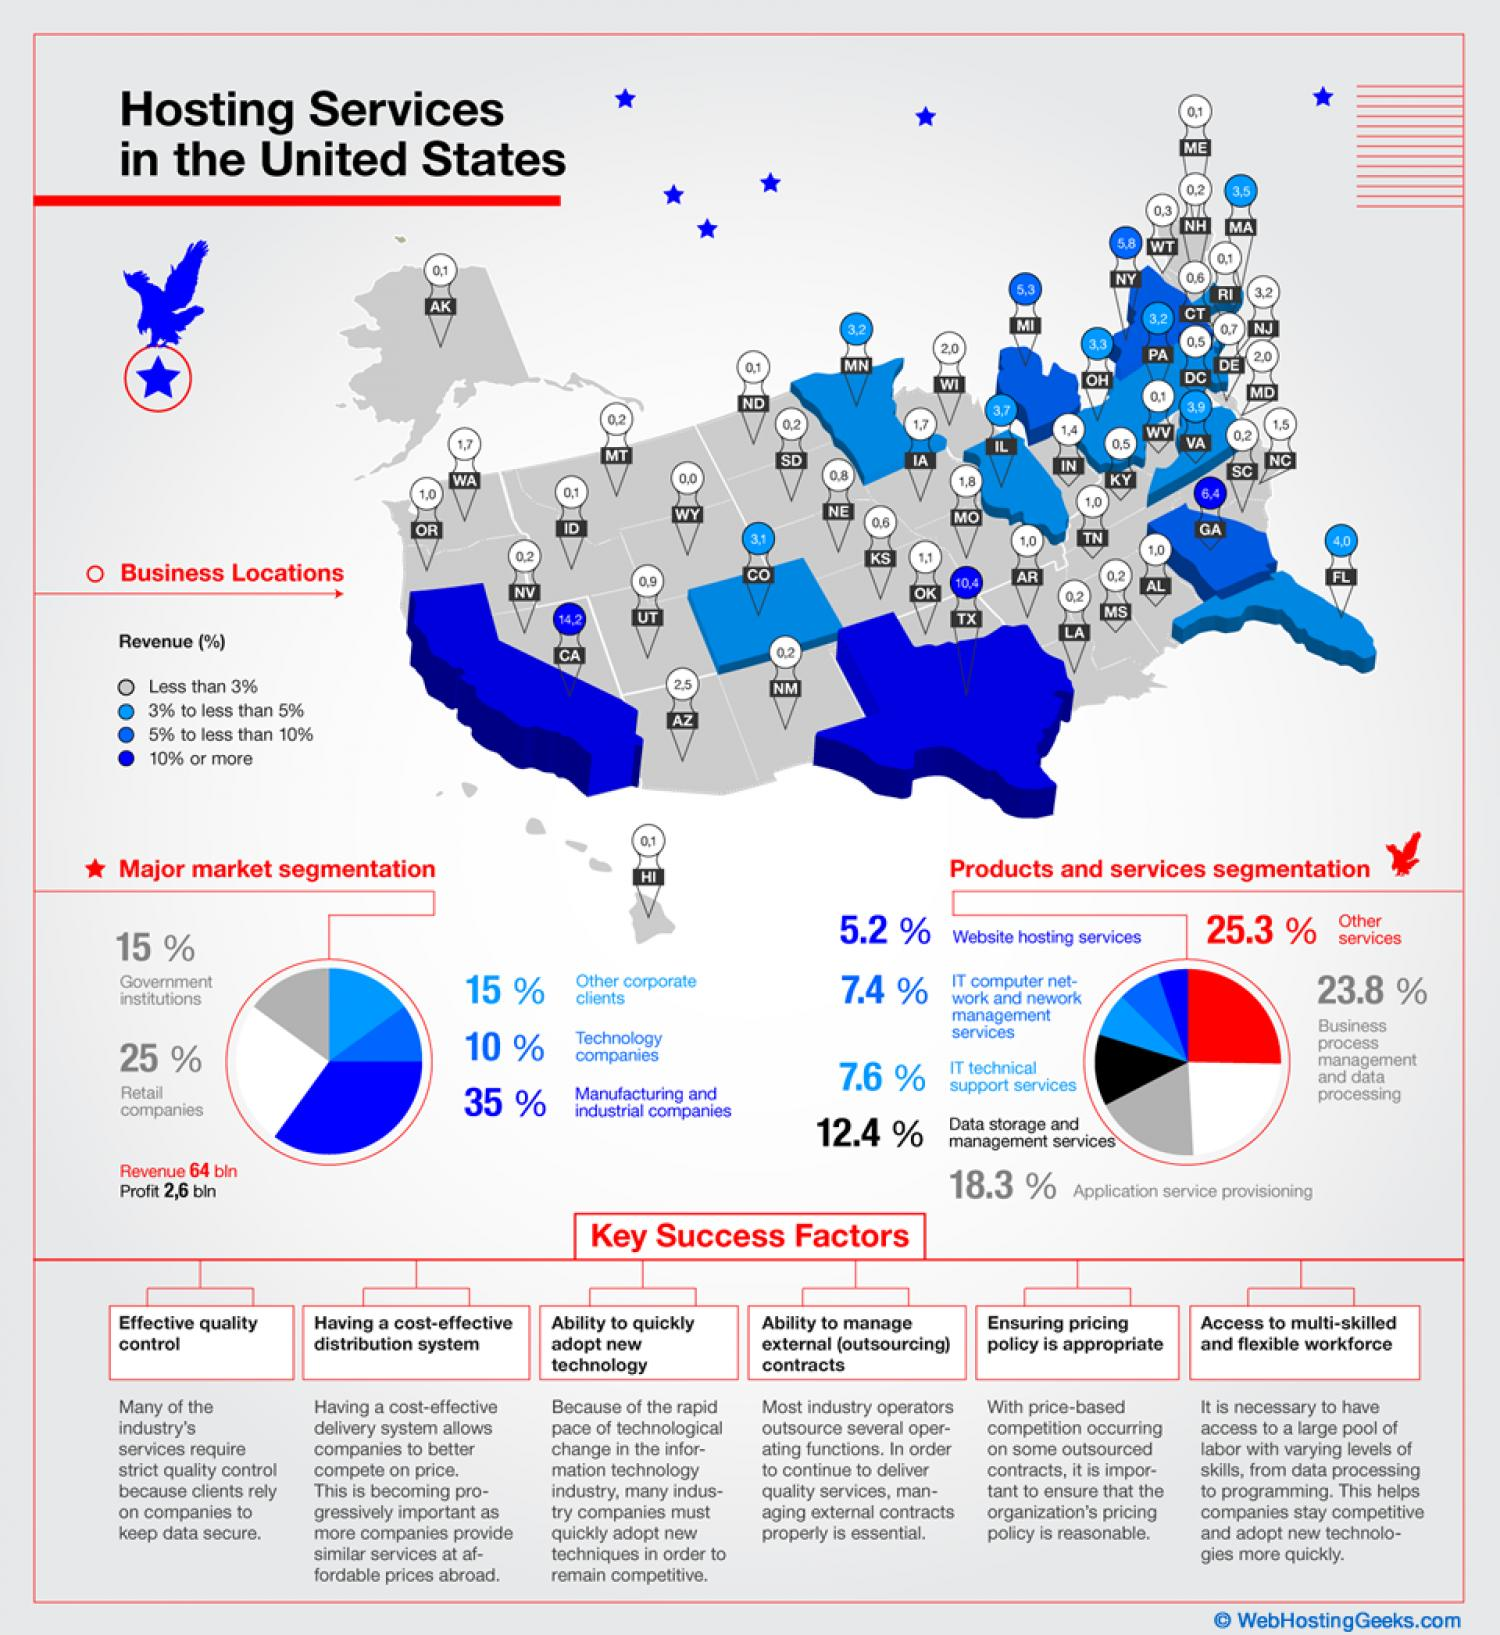Point out several critical features in this image. According to the information provided, approximately 25% of the market is occupied by technology companies and other corporate clients. The third largest product or service in the pie chart is application service provisioning. Of the locations, two have revenue of 10% or more. Six factors are considered key to success. 